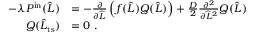Convert formula to latex. <formula><loc_0><loc_0><loc_500><loc_500>\begin{array} { r l } { - \lambda P ^ { i n } ( \widehat { L } ) } & { = - \frac { \partial } { \partial \widehat { L } } \left ( f ( \widehat { L } ) Q ( \widehat { L } ) \right ) + \frac { D } { 2 } \frac { \partial ^ { 2 } } { \partial \widehat { L } ^ { 2 } } Q ( \widehat { L } ) } \\ { Q ( \widehat { L } _ { t s } ) } & { = 0 \ . } \end{array}</formula> 